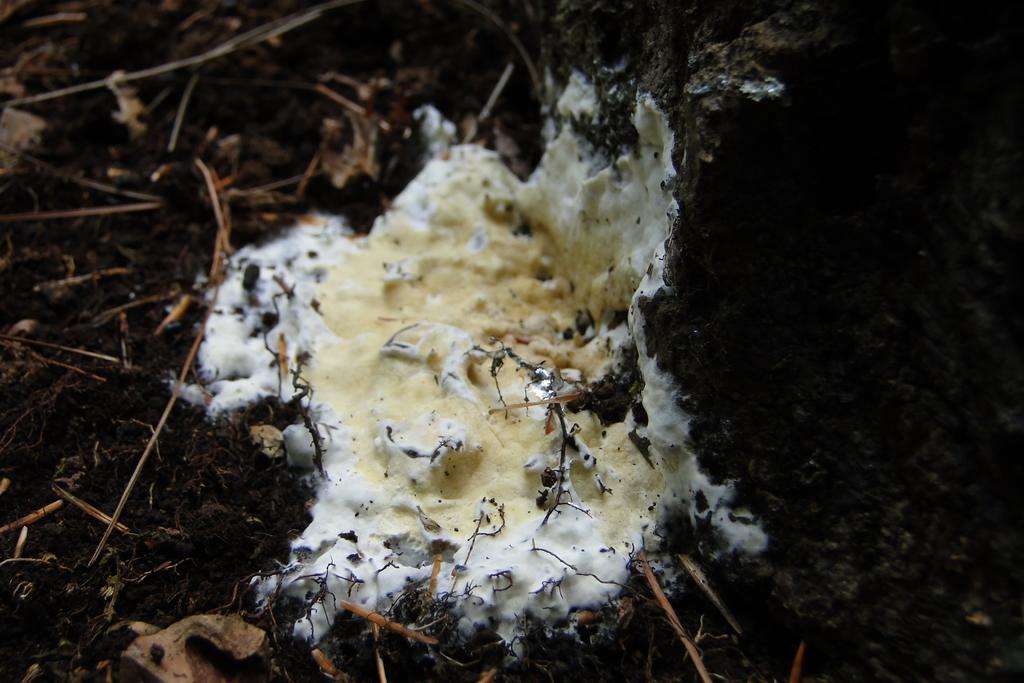Describe this image in one or two sentences. In this picture we can see fungus, rock and grass. 